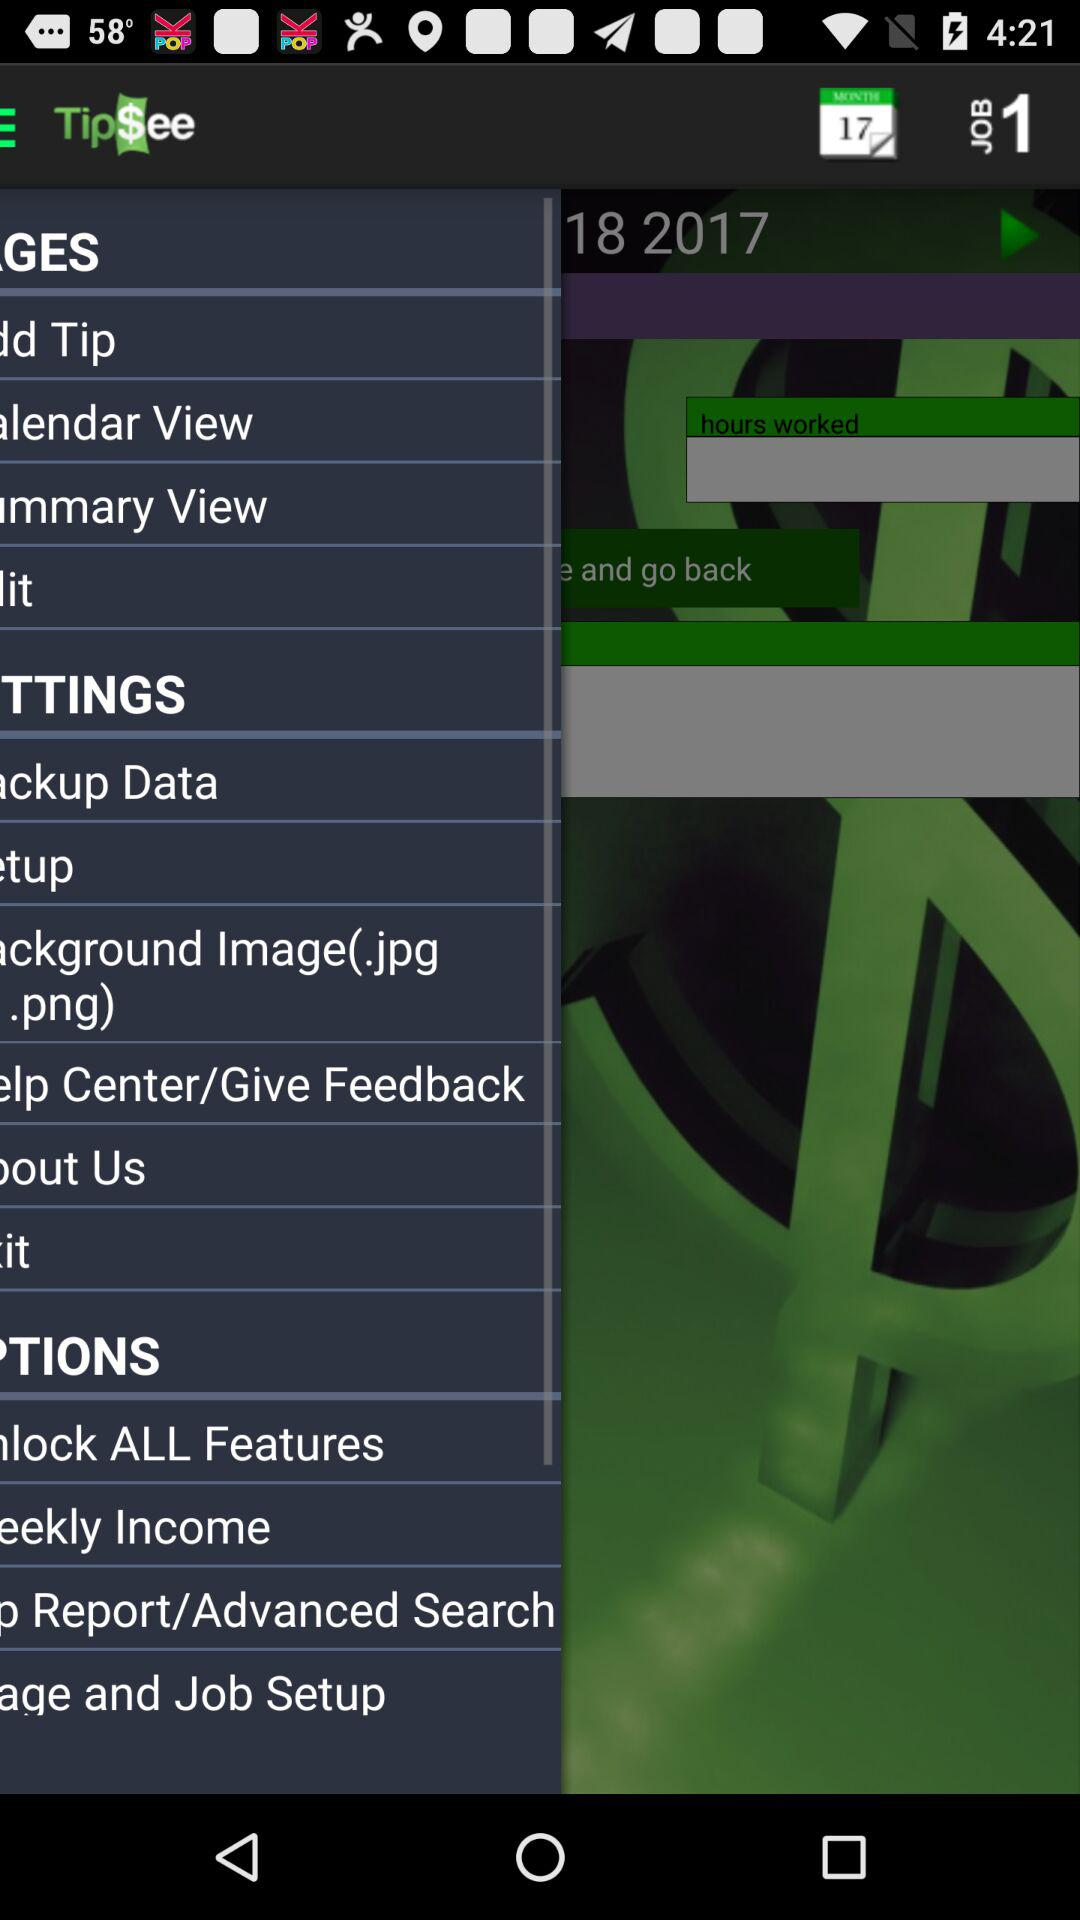What is the lowest hourly pay received?
When the provided information is insufficient, respond with <no answer>. <no answer> 